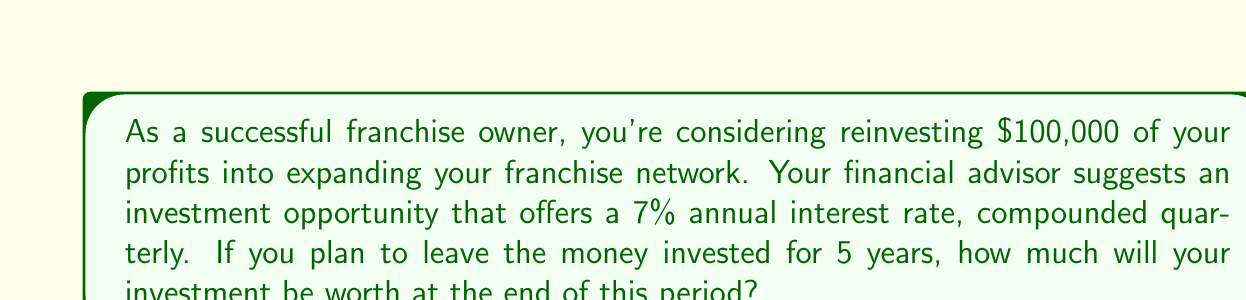Give your solution to this math problem. Let's approach this step-by-step using the compound interest formula:

$$A = P(1 + \frac{r}{n})^{nt}$$

Where:
$A$ = Final amount
$P$ = Principal (initial investment)
$r$ = Annual interest rate (as a decimal)
$n$ = Number of times interest is compounded per year
$t$ = Number of years

Given:
$P = \$100,000$
$r = 0.07$ (7% expressed as a decimal)
$n = 4$ (compounded quarterly, so 4 times per year)
$t = 5$ years

Let's substitute these values into the formula:

$$A = 100,000(1 + \frac{0.07}{4})^{4 * 5}$$

$$A = 100,000(1 + 0.0175)^{20}$$

$$A = 100,000(1.0175)^{20}$$

Using a calculator or computer:

$$A = 100,000 * 1.4185762433$$

$$A = 141,857.62$$

Therefore, after 5 years, the investment will be worth $141,857.62.
Answer: $141,857.62 